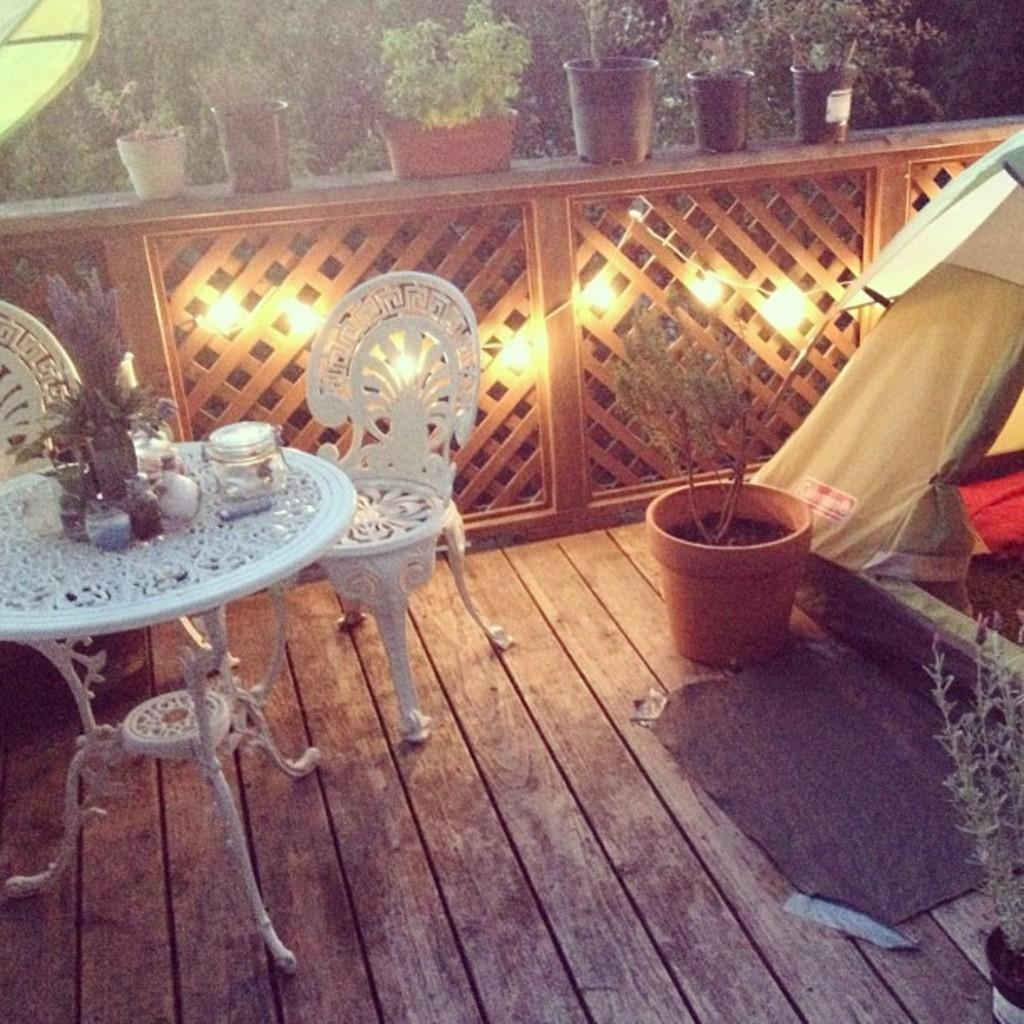What type of furniture is present in the image? There are chairs and a table in the image. What is placed on the floor in the image? There is a tent on the floor in the image. What type of plant can be seen in the image? There is a house plant in the image, and additional house plants are visible in the background. What can be seen in the background of the image? In the background, there are lights visible, as well as trees. What is the title of the invention depicted in the image? There is no invention present in the image, so there is no title to be determined. What force is being applied to the tent in the image? There is no force being applied to the tent in the image; it is simply placed on the floor. 